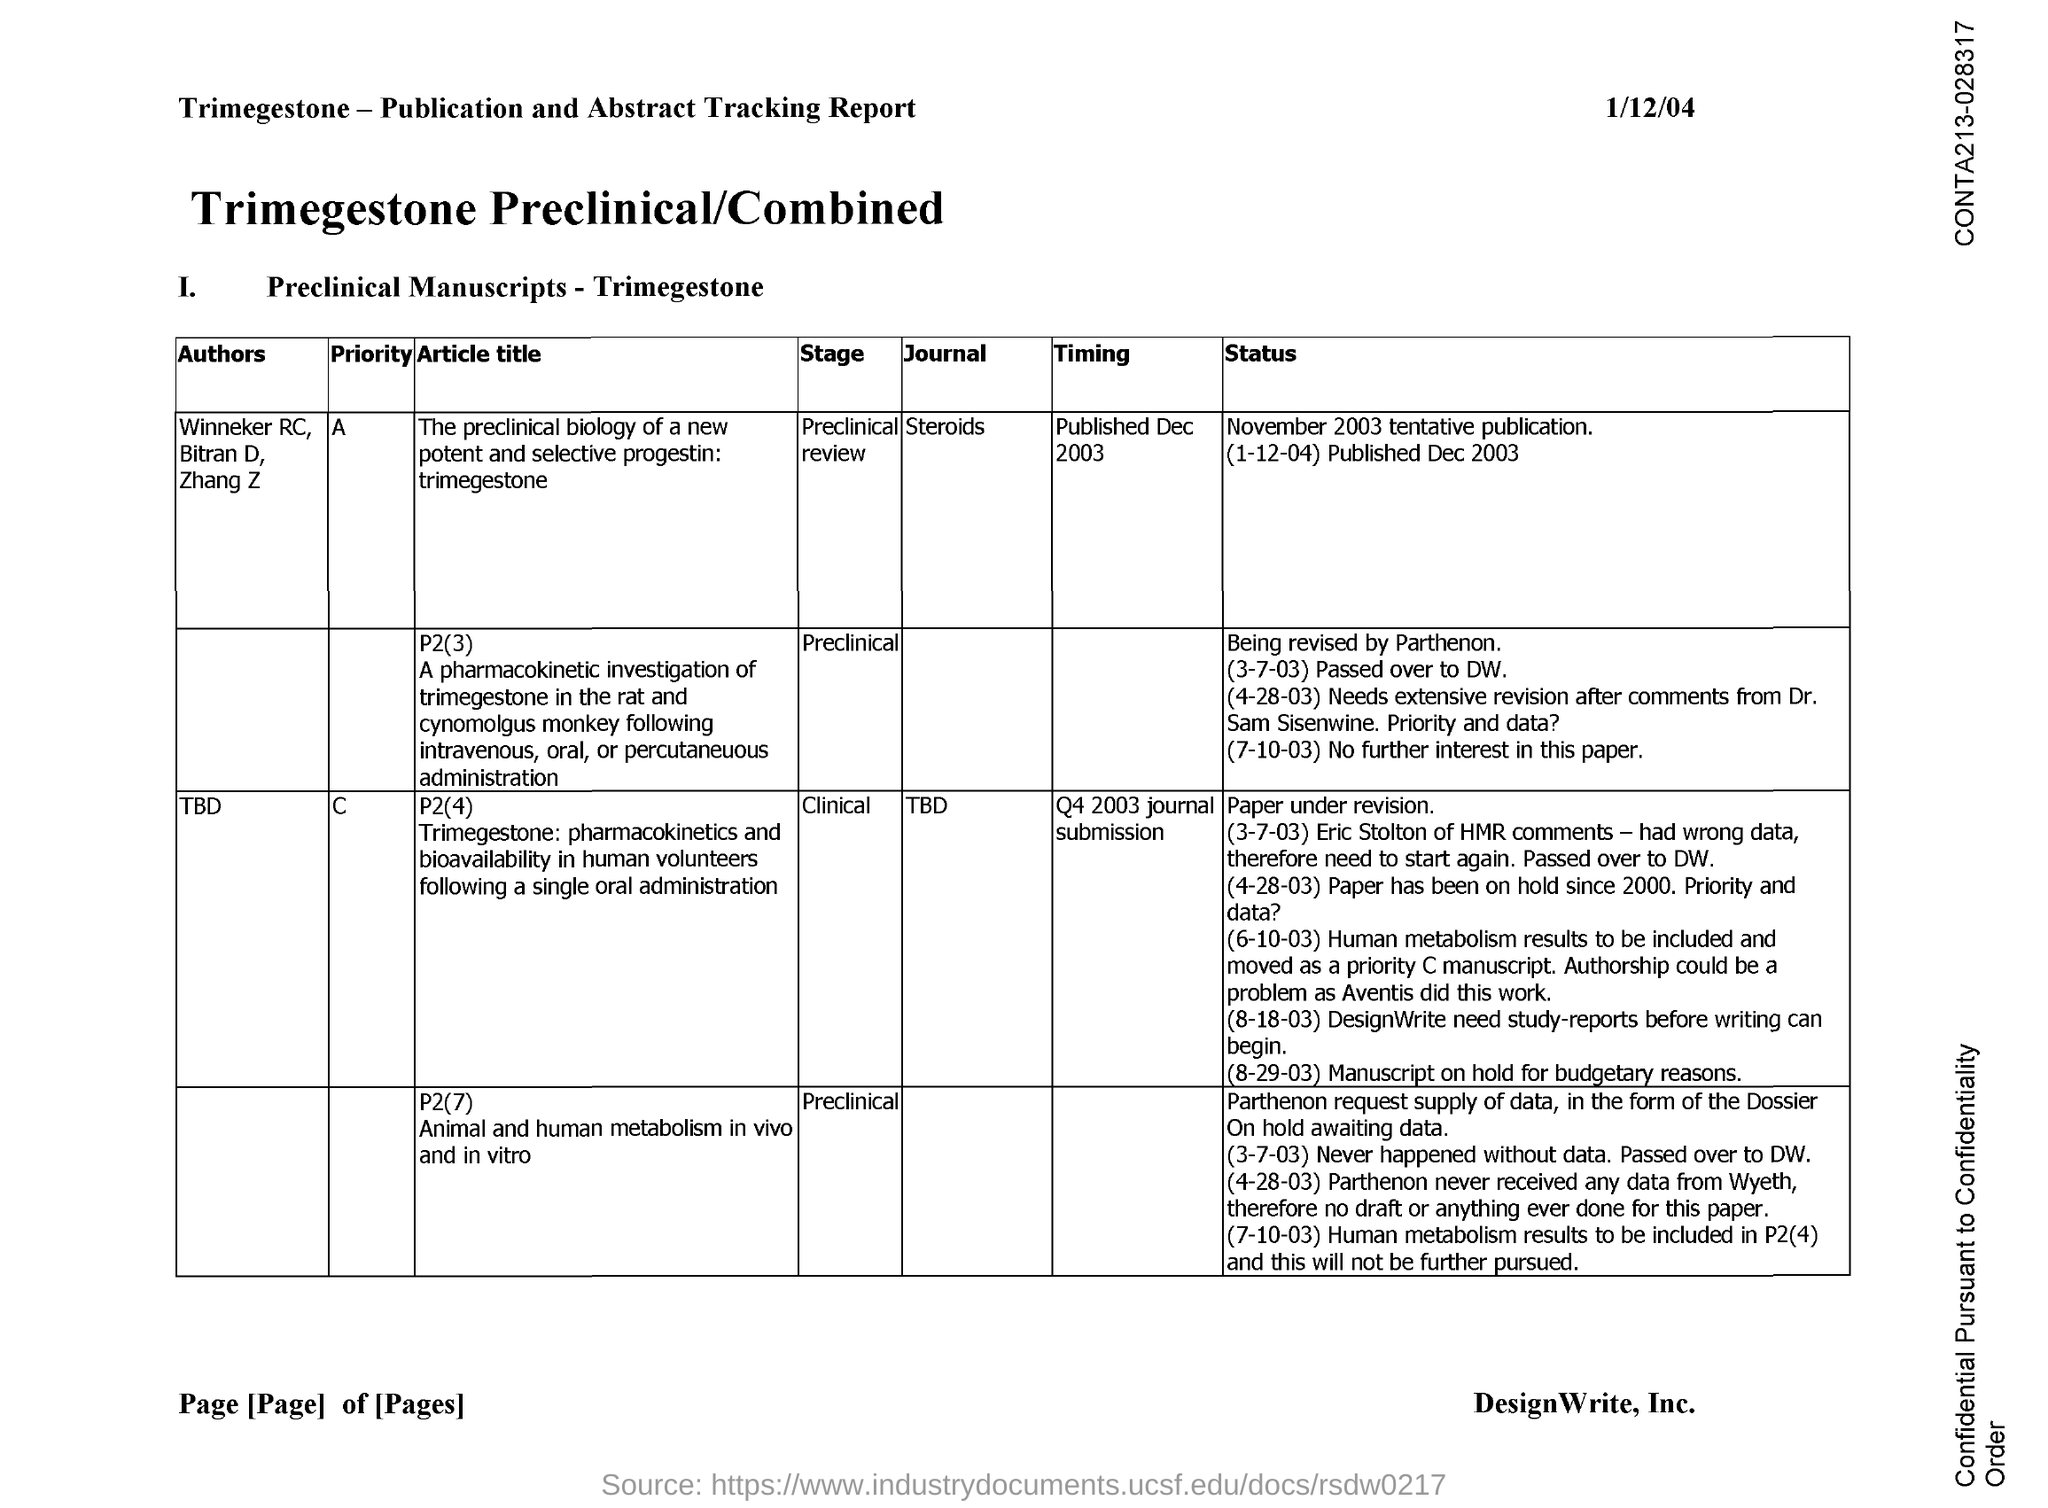Mention a couple of crucial points in this snapshot. The journal article "Steroids," published in December 2003, provides information on the timing of its publication. The date indicated on the document is January 12th, 2004. 